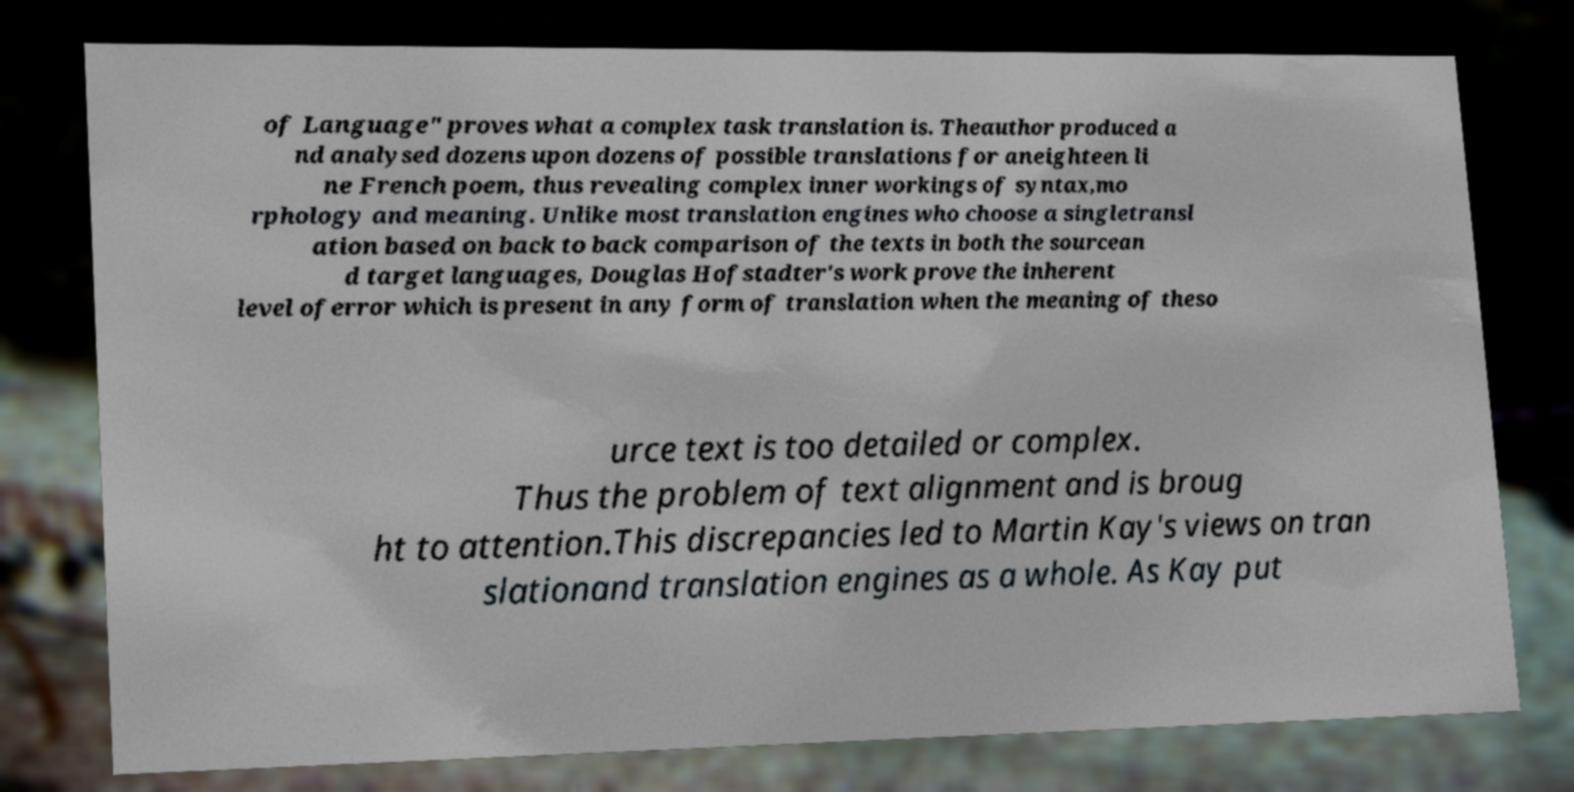For documentation purposes, I need the text within this image transcribed. Could you provide that? of Language" proves what a complex task translation is. Theauthor produced a nd analysed dozens upon dozens of possible translations for aneighteen li ne French poem, thus revealing complex inner workings of syntax,mo rphology and meaning. Unlike most translation engines who choose a singletransl ation based on back to back comparison of the texts in both the sourcean d target languages, Douglas Hofstadter's work prove the inherent level oferror which is present in any form of translation when the meaning of theso urce text is too detailed or complex. Thus the problem of text alignment and is broug ht to attention.This discrepancies led to Martin Kay's views on tran slationand translation engines as a whole. As Kay put 